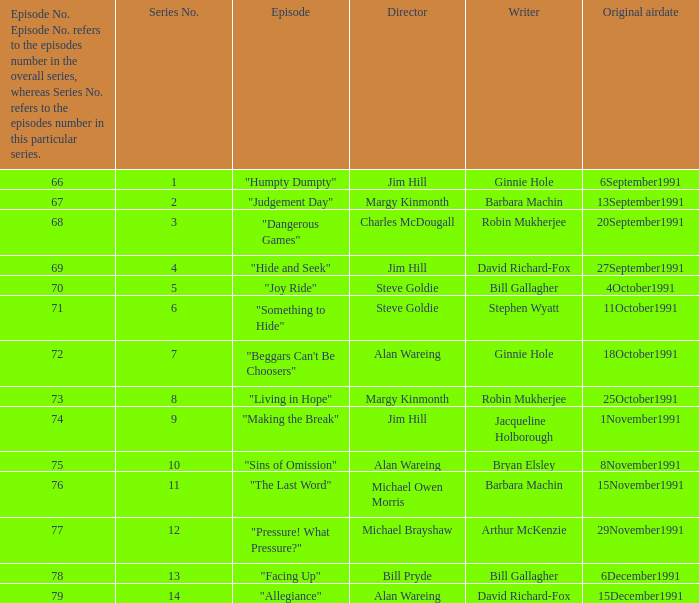Name the original airdate for robin mukherjee and margy kinmonth 25October1991. 